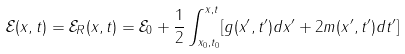<formula> <loc_0><loc_0><loc_500><loc_500>\mathcal { E } ( x , t ) = \mathcal { E } _ { R } ( x , t ) = \mathcal { E } _ { 0 } + \frac { 1 } { 2 } \int _ { x _ { 0 } , t _ { 0 } } ^ { x , t } [ g ( x ^ { \prime } , t ^ { \prime } ) d x ^ { \prime } + 2 m ( x ^ { \prime } , t ^ { \prime } ) d t ^ { \prime } ]</formula> 